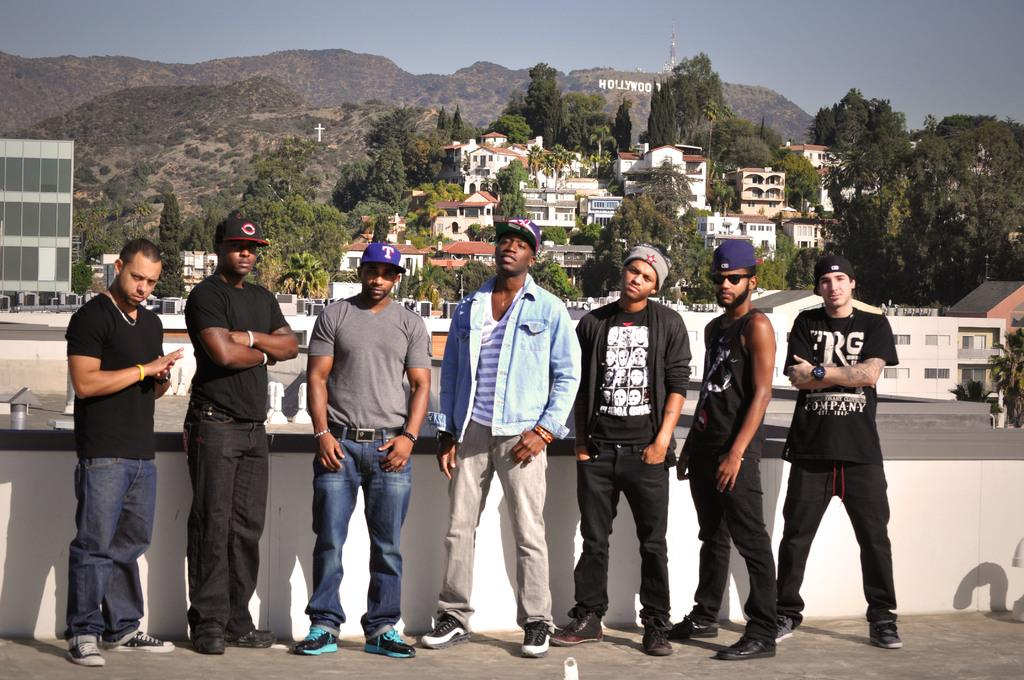How many people are in the group in the image? There is a group of people in the image, but the exact number cannot be determined from the provided facts. What are some people in the group wearing? Some people in the group are wearing caps. What can be seen in the background of the image? Buildings, trees, hills, and a tower are visible in the background. What type of flowers are growing on the hills in the image? There are no flowers visible on the hills in the image; only trees and buildings can be seen. 